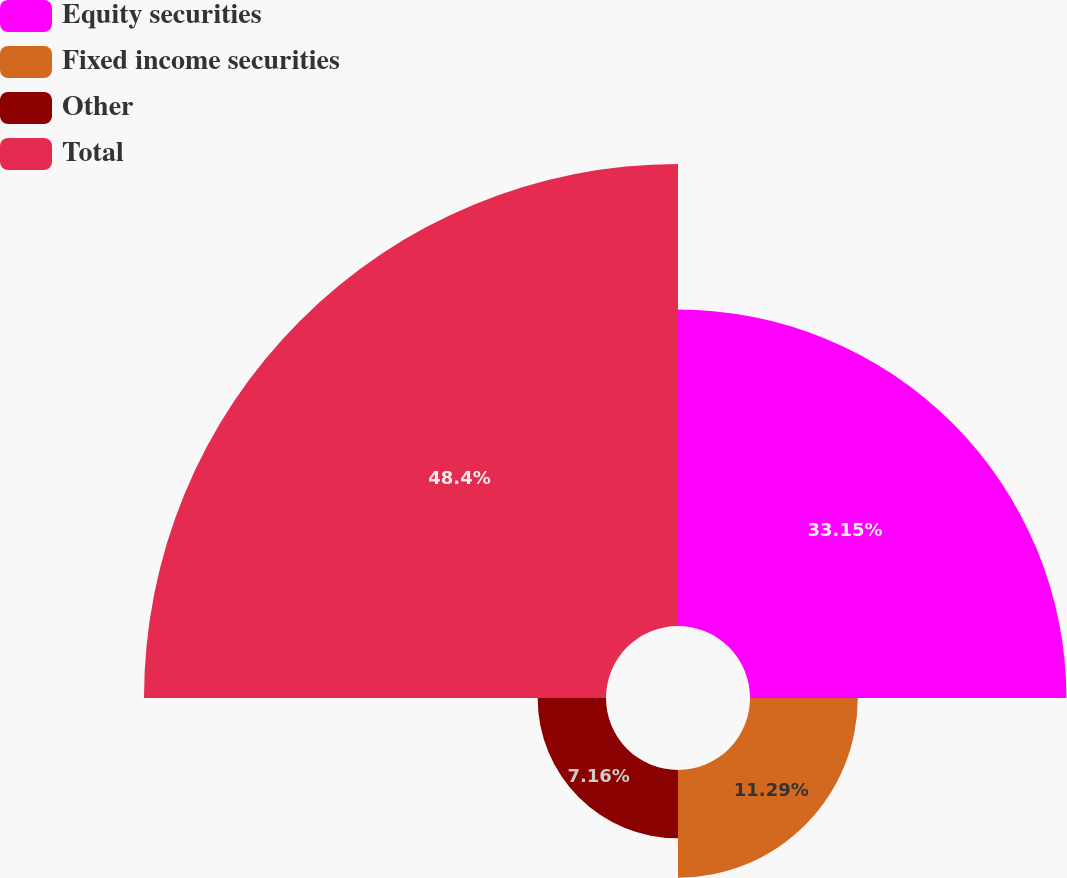Convert chart to OTSL. <chart><loc_0><loc_0><loc_500><loc_500><pie_chart><fcel>Equity securities<fcel>Fixed income securities<fcel>Other<fcel>Total<nl><fcel>33.15%<fcel>11.29%<fcel>7.16%<fcel>48.4%<nl></chart> 